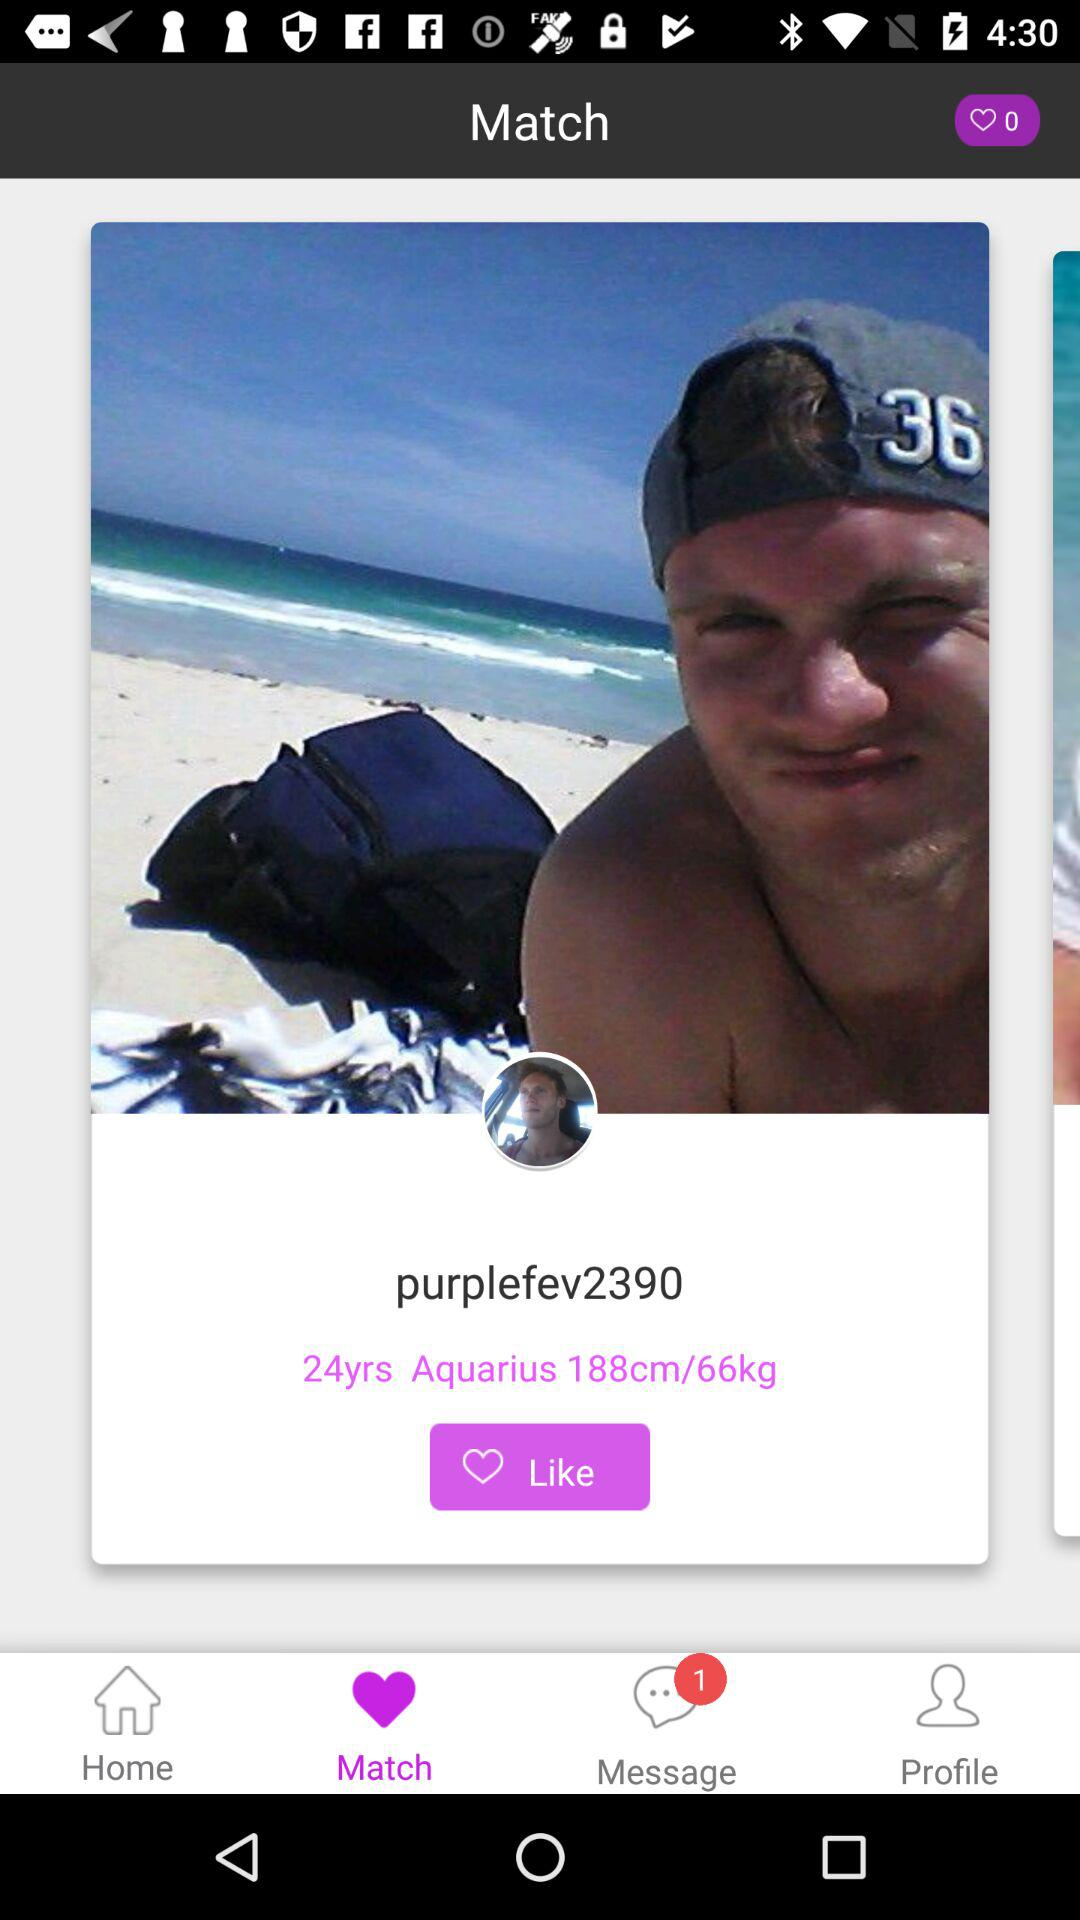What is the weight of "purplefev2390"? The weight is 66 kg. 